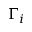<formula> <loc_0><loc_0><loc_500><loc_500>\Gamma _ { i }</formula> 